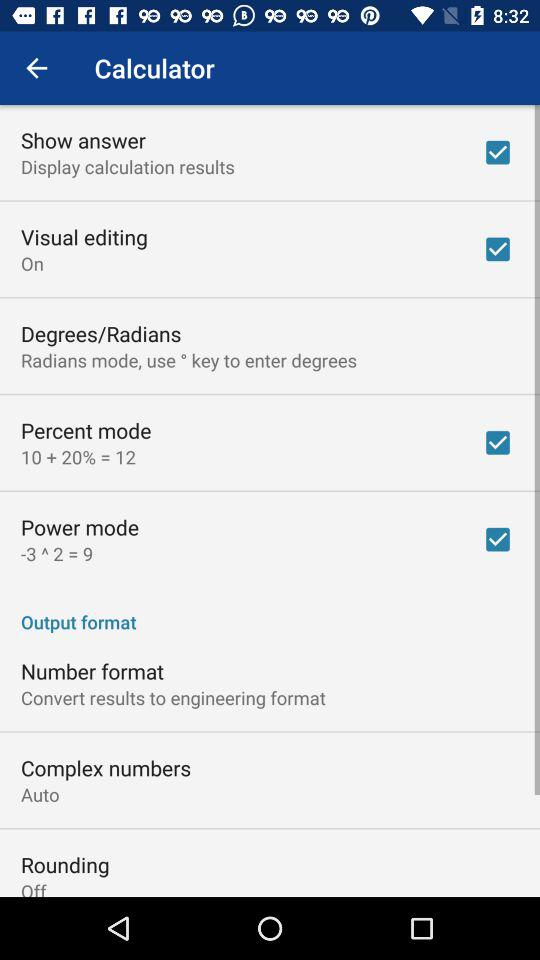What is the setting for complex numbers? The setting for complex numbers is "Auto". 